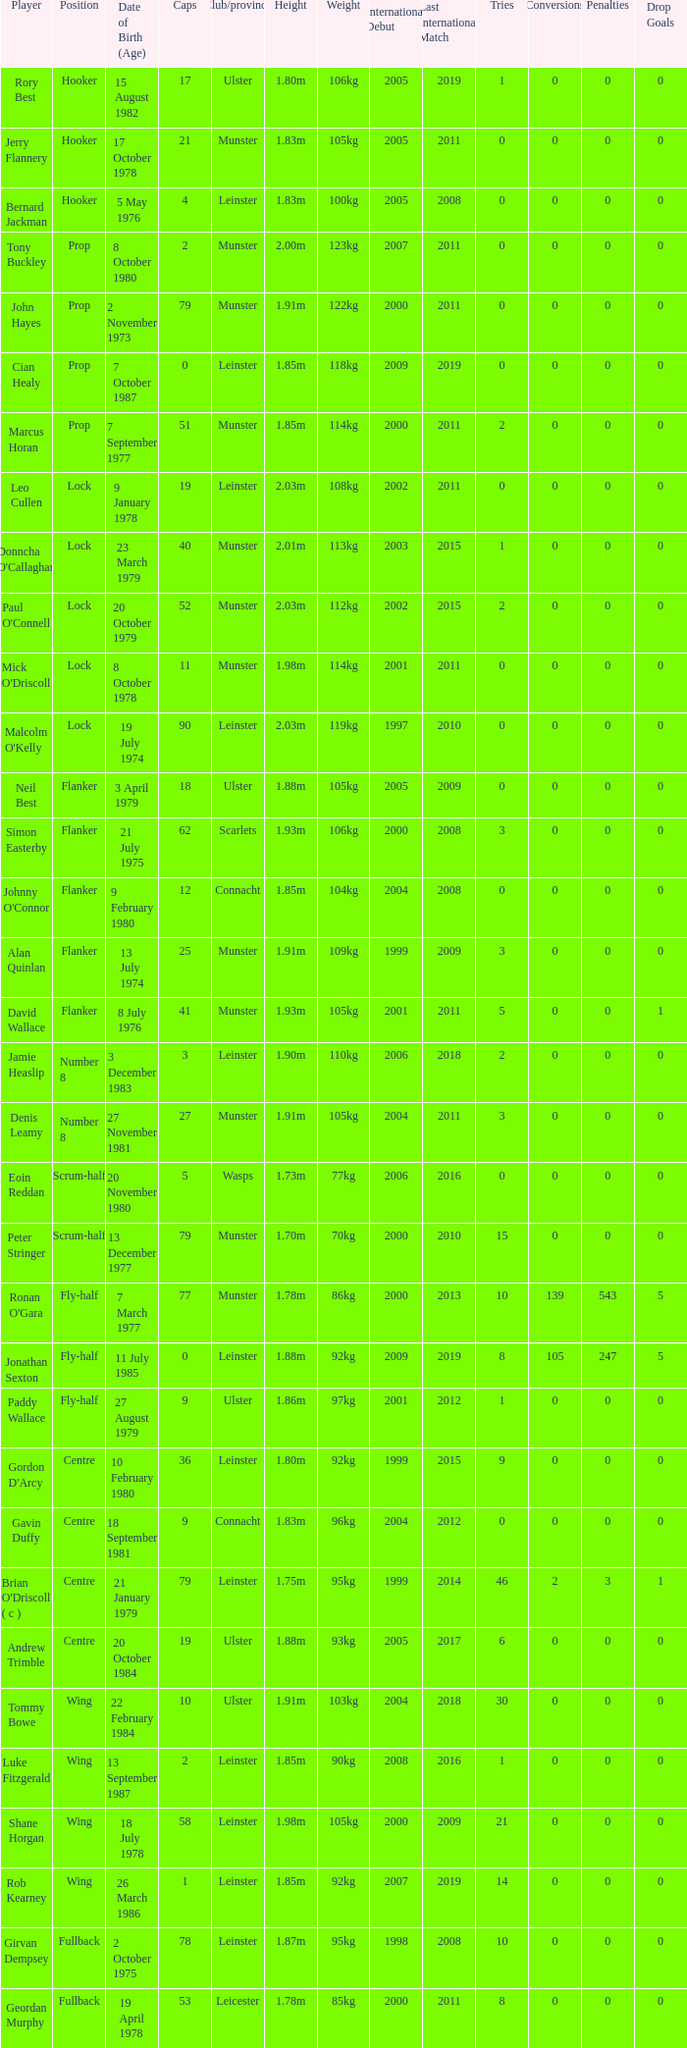What is the total of Caps when player born 13 December 1977? 79.0. 